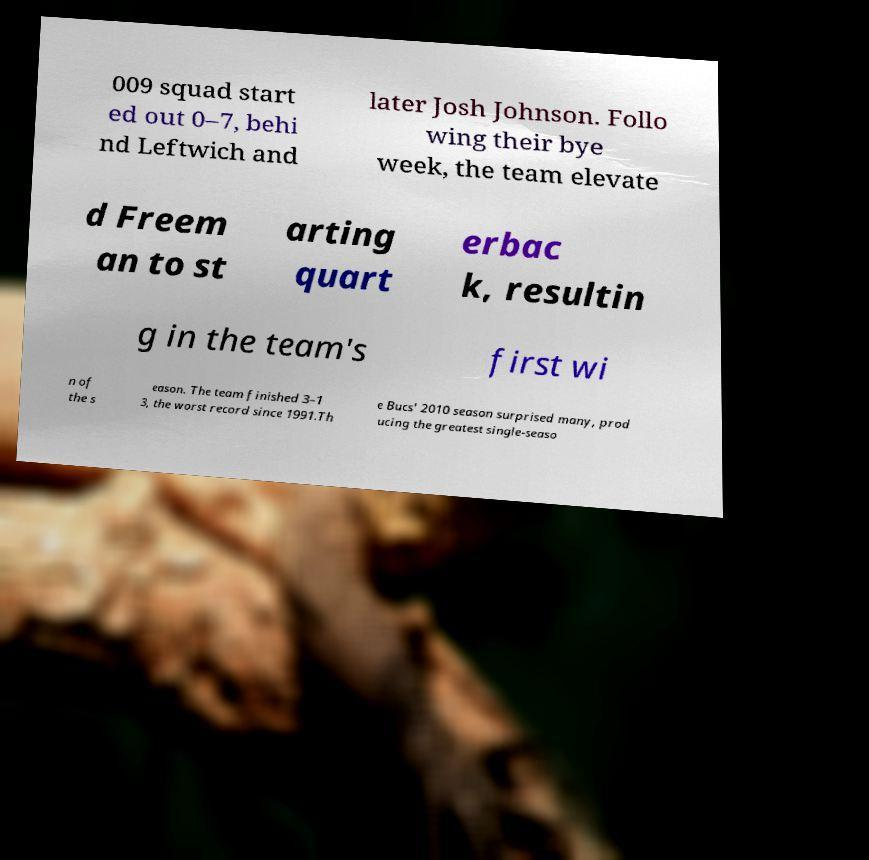There's text embedded in this image that I need extracted. Can you transcribe it verbatim? 009 squad start ed out 0–7, behi nd Leftwich and later Josh Johnson. Follo wing their bye week, the team elevate d Freem an to st arting quart erbac k, resultin g in the team's first wi n of the s eason. The team finished 3–1 3, the worst record since 1991.Th e Bucs' 2010 season surprised many, prod ucing the greatest single-seaso 